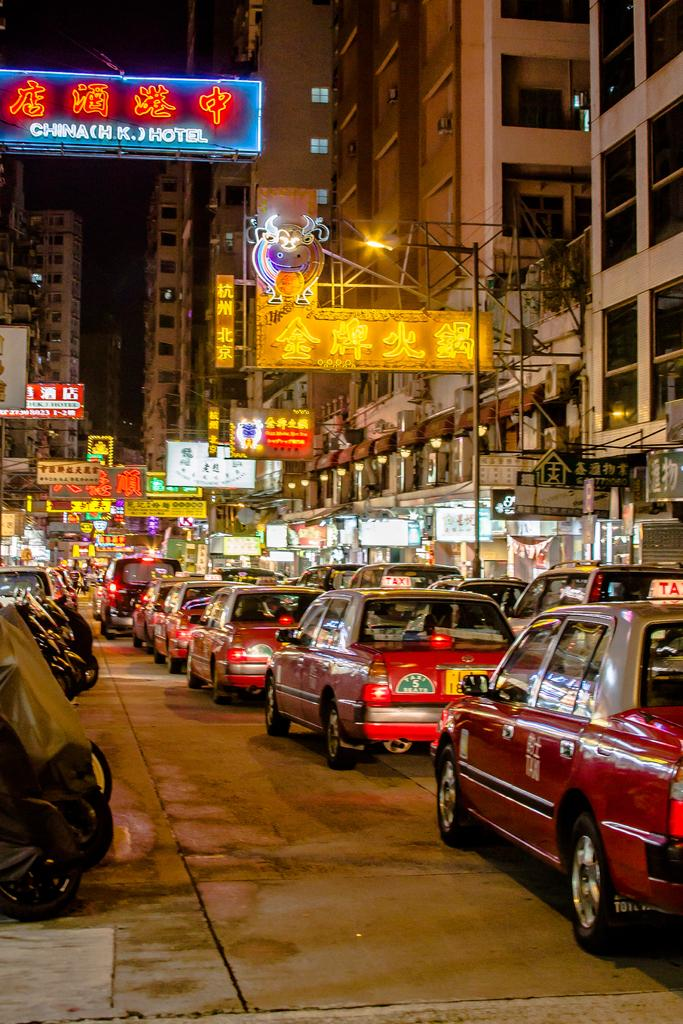<image>
Present a compact description of the photo's key features. A busy street scene with a sign for the China (HK) Hotel. 